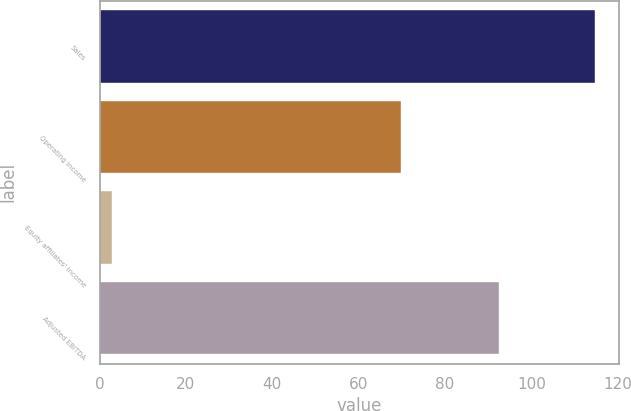Convert chart. <chart><loc_0><loc_0><loc_500><loc_500><bar_chart><fcel>Sales<fcel>Operating income<fcel>Equity affiliates' income<fcel>Adjusted EBITDA<nl><fcel>114.7<fcel>69.8<fcel>2.8<fcel>92.5<nl></chart> 